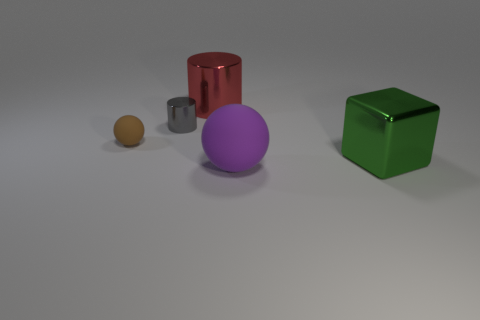Add 3 large blocks. How many objects exist? 8 Subtract all balls. How many objects are left? 3 Subtract all purple balls. How many balls are left? 1 Subtract 0 brown cylinders. How many objects are left? 5 Subtract 1 blocks. How many blocks are left? 0 Subtract all yellow spheres. Subtract all cyan blocks. How many spheres are left? 2 Subtract all brown cylinders. How many brown blocks are left? 0 Subtract all large purple matte cylinders. Subtract all tiny gray cylinders. How many objects are left? 4 Add 3 tiny rubber things. How many tiny rubber things are left? 4 Add 1 small cyan balls. How many small cyan balls exist? 1 